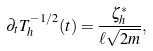Convert formula to latex. <formula><loc_0><loc_0><loc_500><loc_500>\partial _ { t } T _ { h } ^ { - 1 / 2 } ( t ) = \frac { \zeta _ { h } ^ { \ast } } { \ell \sqrt { 2 m } } ,</formula> 